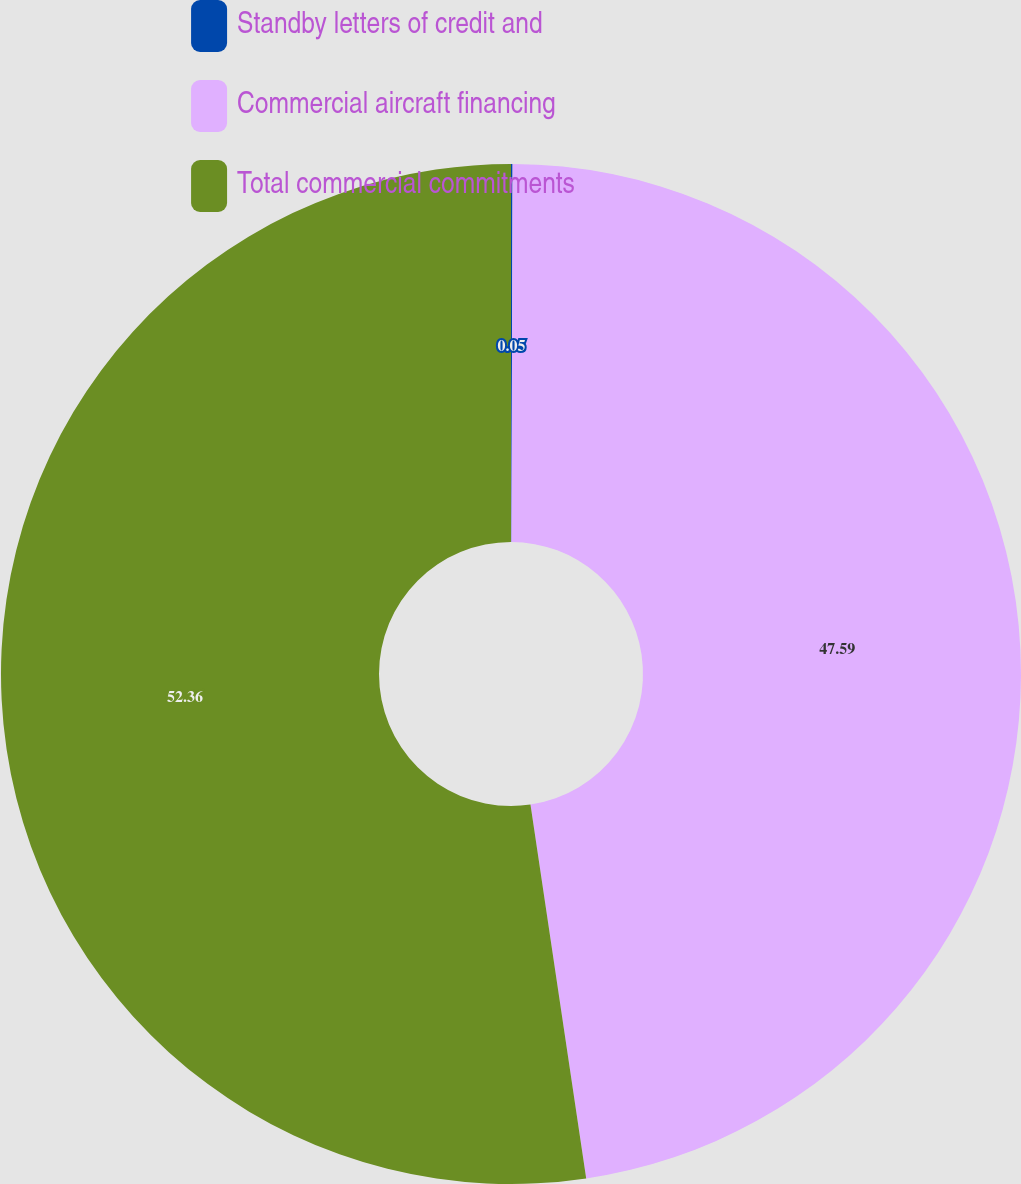<chart> <loc_0><loc_0><loc_500><loc_500><pie_chart><fcel>Standby letters of credit and<fcel>Commercial aircraft financing<fcel>Total commercial commitments<nl><fcel>0.05%<fcel>47.59%<fcel>52.35%<nl></chart> 